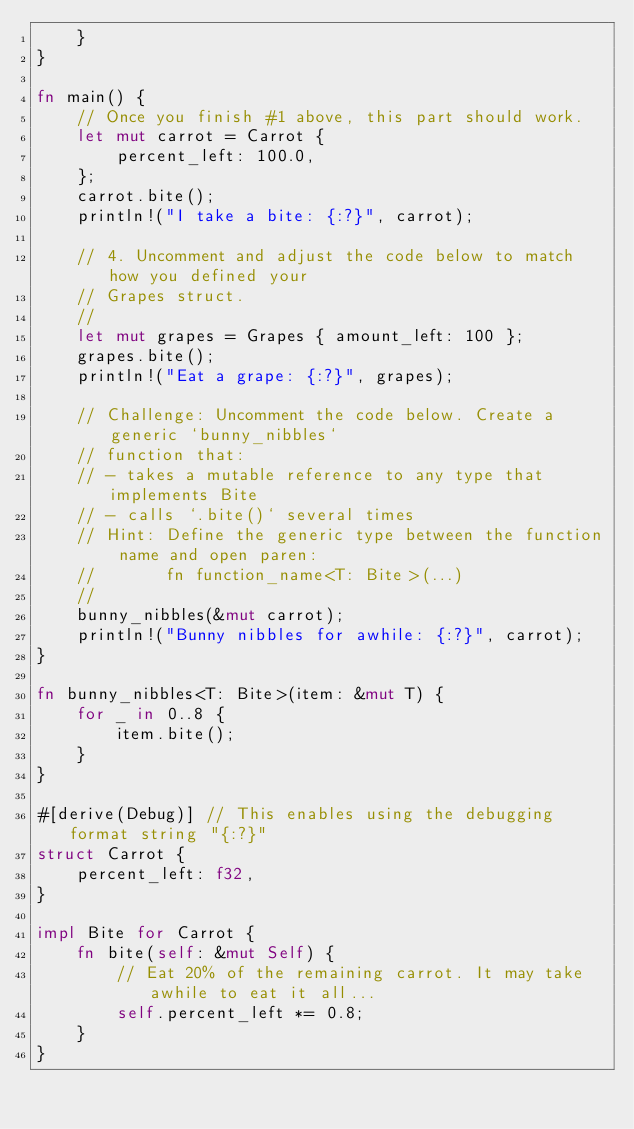<code> <loc_0><loc_0><loc_500><loc_500><_Rust_>    }
}

fn main() {
    // Once you finish #1 above, this part should work.
    let mut carrot = Carrot {
        percent_left: 100.0,
    };
    carrot.bite();
    println!("I take a bite: {:?}", carrot);

    // 4. Uncomment and adjust the code below to match how you defined your
    // Grapes struct.
    //
    let mut grapes = Grapes { amount_left: 100 };
    grapes.bite();
    println!("Eat a grape: {:?}", grapes);

    // Challenge: Uncomment the code below. Create a generic `bunny_nibbles`
    // function that:
    // - takes a mutable reference to any type that implements Bite
    // - calls `.bite()` several times
    // Hint: Define the generic type between the function name and open paren:
    //       fn function_name<T: Bite>(...)
    //
    bunny_nibbles(&mut carrot);
    println!("Bunny nibbles for awhile: {:?}", carrot);
}

fn bunny_nibbles<T: Bite>(item: &mut T) {
    for _ in 0..8 {
        item.bite();
    }
}

#[derive(Debug)] // This enables using the debugging format string "{:?}"
struct Carrot {
    percent_left: f32,
}

impl Bite for Carrot {
    fn bite(self: &mut Self) {
        // Eat 20% of the remaining carrot. It may take awhile to eat it all...
        self.percent_left *= 0.8;
    }
}

</code> 